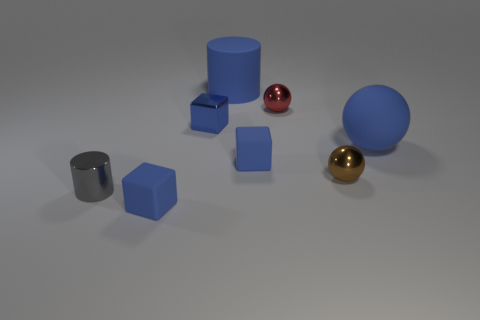Add 2 blue rubber spheres. How many objects exist? 10 Subtract all spheres. How many objects are left? 5 Add 1 tiny gray cylinders. How many tiny gray cylinders exist? 2 Subtract 0 purple cylinders. How many objects are left? 8 Subtract all large blue rubber balls. Subtract all small rubber cubes. How many objects are left? 5 Add 3 rubber spheres. How many rubber spheres are left? 4 